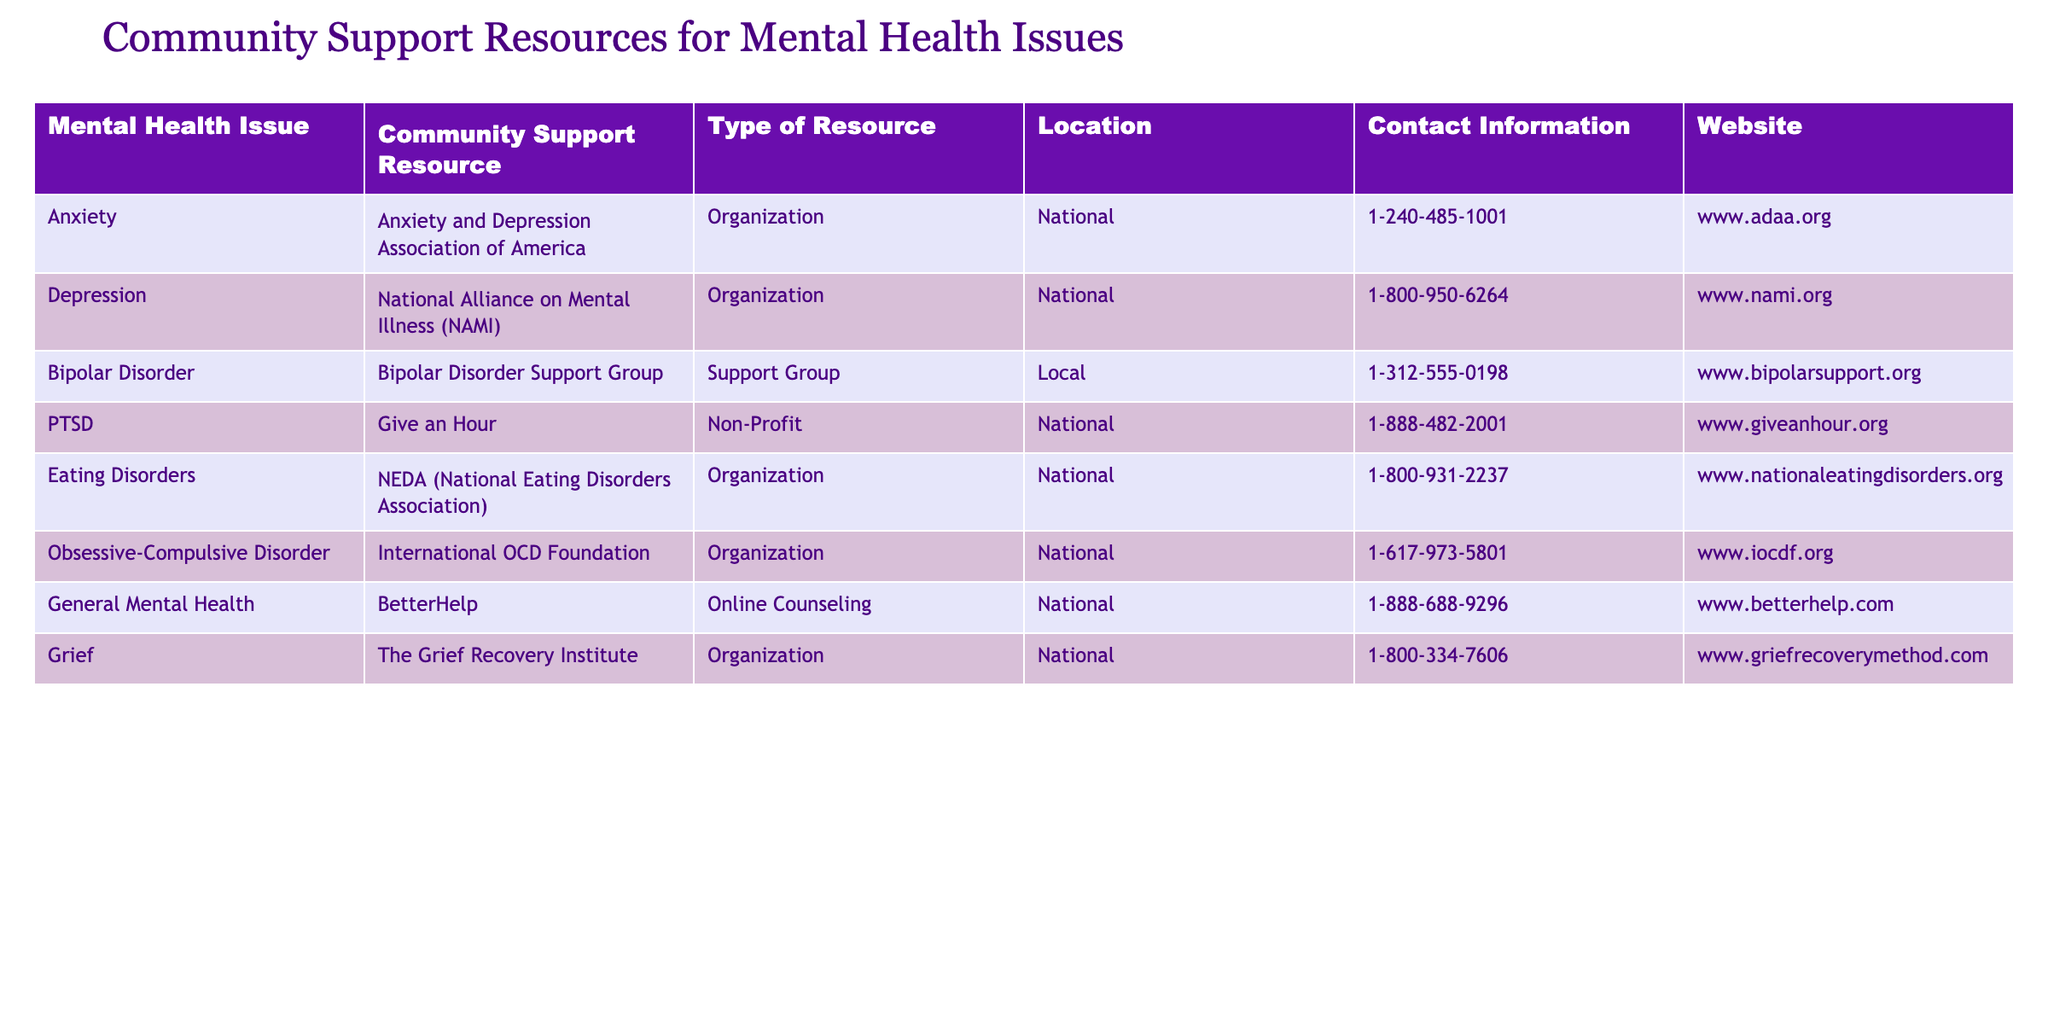What is the contact number for the National Alliance on Mental Illness (NAMI)? The contact information for NAMI is listed directly in the table. The number provided is 1-800-950-6264.
Answer: 1-800-950-6264 How many support resources are available for national mental health issues? By reviewing the 'Location' column, we identify the resources that are labeled as 'National.' There are a total of 6 entries in the table that are categorized as national resources.
Answer: 6 Is there a specific resource for Bipolar Disorder? The table includes a listing for Bipolar Disorder under the 'Mental Health Issue' column. The associated resource is the Bipolar Disorder Support Group.
Answer: Yes Which organization provides resources for Eating Disorders? The table specifically mentions that the National Eating Disorders Association (NEDA) offers support for Eating Disorders, found in the 'Community Support Resource' column.
Answer: NEDA (National Eating Disorders Association) What is the primary type of resource available for PTSD? Looking at the corresponding row in the table for PTSD, it shows that the type of resource available is labeled as 'Non-Profit.'
Answer: Non-Profit How many different types of resources are identified in the table? To find the different types of resources, we can list them from the 'Type of Resource' column. The types are Organization, Support Group, Non-Profit, and Online Counseling. Thus, there are a total of 4 different types.
Answer: 4 What is the website for BetterHelp? The website for BetterHelp is clearly stated in the 'Website' column of the table as www.betterhelp.com.
Answer: www.betterhelp.com Which mental health issue has a local support resource? By examining the table, the 'Bipolar Disorder' support resource indicates it is a 'Local' support group, as noted in the 'Location' column.
Answer: Bipolar Disorder If you wanted to contact the International OCD Foundation, what number would you call? The contact number for the International OCD Foundation is found in the table, which lists it as 1-617-973-5801.
Answer: 1-617-973-5801 Are there any resources specifically for Grief? Yes, the table includes The Grief Recovery Institute as a resource specifically aimed at addressing Grief, as noted in the 'Mental Health Issue' column.
Answer: Yes 